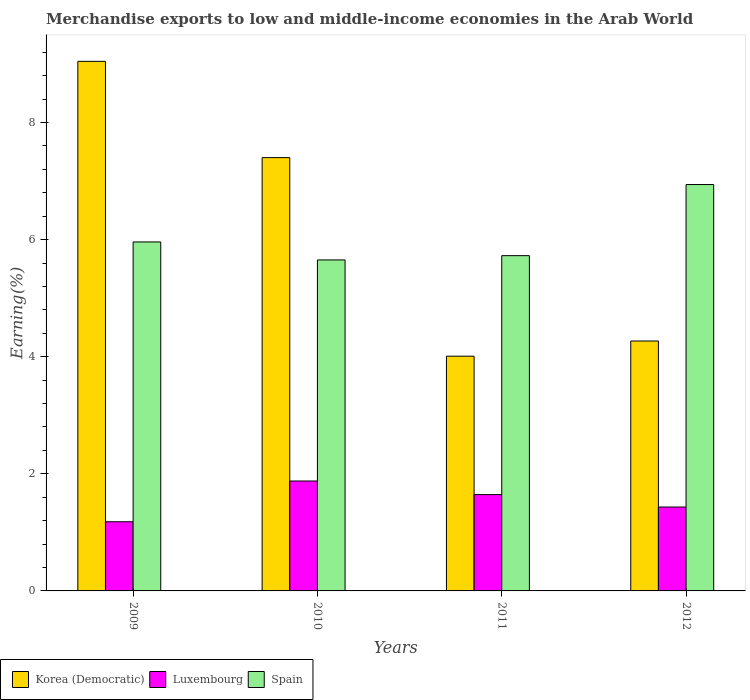How many different coloured bars are there?
Your answer should be compact. 3. How many groups of bars are there?
Give a very brief answer. 4. How many bars are there on the 1st tick from the right?
Keep it short and to the point. 3. What is the percentage of amount earned from merchandise exports in Korea (Democratic) in 2010?
Provide a short and direct response. 7.4. Across all years, what is the maximum percentage of amount earned from merchandise exports in Spain?
Make the answer very short. 6.94. Across all years, what is the minimum percentage of amount earned from merchandise exports in Luxembourg?
Give a very brief answer. 1.18. What is the total percentage of amount earned from merchandise exports in Luxembourg in the graph?
Offer a very short reply. 6.14. What is the difference between the percentage of amount earned from merchandise exports in Korea (Democratic) in 2010 and that in 2011?
Ensure brevity in your answer.  3.39. What is the difference between the percentage of amount earned from merchandise exports in Luxembourg in 2011 and the percentage of amount earned from merchandise exports in Spain in 2009?
Offer a terse response. -4.32. What is the average percentage of amount earned from merchandise exports in Spain per year?
Make the answer very short. 6.07. In the year 2012, what is the difference between the percentage of amount earned from merchandise exports in Luxembourg and percentage of amount earned from merchandise exports in Korea (Democratic)?
Ensure brevity in your answer.  -2.84. What is the ratio of the percentage of amount earned from merchandise exports in Spain in 2010 to that in 2011?
Keep it short and to the point. 0.99. What is the difference between the highest and the second highest percentage of amount earned from merchandise exports in Korea (Democratic)?
Ensure brevity in your answer.  1.64. What is the difference between the highest and the lowest percentage of amount earned from merchandise exports in Spain?
Offer a very short reply. 1.29. Is the sum of the percentage of amount earned from merchandise exports in Spain in 2009 and 2010 greater than the maximum percentage of amount earned from merchandise exports in Korea (Democratic) across all years?
Offer a very short reply. Yes. What does the 2nd bar from the right in 2010 represents?
Offer a very short reply. Luxembourg. How many bars are there?
Your answer should be very brief. 12. Are all the bars in the graph horizontal?
Provide a succinct answer. No. How many years are there in the graph?
Your answer should be compact. 4. What is the difference between two consecutive major ticks on the Y-axis?
Offer a very short reply. 2. Does the graph contain any zero values?
Your response must be concise. No. Does the graph contain grids?
Provide a succinct answer. No. Where does the legend appear in the graph?
Offer a terse response. Bottom left. How are the legend labels stacked?
Keep it short and to the point. Horizontal. What is the title of the graph?
Give a very brief answer. Merchandise exports to low and middle-income economies in the Arab World. Does "Fragile and conflict affected situations" appear as one of the legend labels in the graph?
Keep it short and to the point. No. What is the label or title of the X-axis?
Make the answer very short. Years. What is the label or title of the Y-axis?
Make the answer very short. Earning(%). What is the Earning(%) in Korea (Democratic) in 2009?
Provide a succinct answer. 9.04. What is the Earning(%) of Luxembourg in 2009?
Provide a succinct answer. 1.18. What is the Earning(%) in Spain in 2009?
Offer a very short reply. 5.96. What is the Earning(%) of Korea (Democratic) in 2010?
Make the answer very short. 7.4. What is the Earning(%) in Luxembourg in 2010?
Provide a short and direct response. 1.88. What is the Earning(%) of Spain in 2010?
Your response must be concise. 5.65. What is the Earning(%) in Korea (Democratic) in 2011?
Ensure brevity in your answer.  4.01. What is the Earning(%) of Luxembourg in 2011?
Offer a very short reply. 1.65. What is the Earning(%) of Spain in 2011?
Your response must be concise. 5.73. What is the Earning(%) in Korea (Democratic) in 2012?
Make the answer very short. 4.27. What is the Earning(%) of Luxembourg in 2012?
Keep it short and to the point. 1.43. What is the Earning(%) in Spain in 2012?
Provide a succinct answer. 6.94. Across all years, what is the maximum Earning(%) of Korea (Democratic)?
Offer a very short reply. 9.04. Across all years, what is the maximum Earning(%) in Luxembourg?
Your answer should be very brief. 1.88. Across all years, what is the maximum Earning(%) of Spain?
Provide a succinct answer. 6.94. Across all years, what is the minimum Earning(%) in Korea (Democratic)?
Your answer should be compact. 4.01. Across all years, what is the minimum Earning(%) of Luxembourg?
Make the answer very short. 1.18. Across all years, what is the minimum Earning(%) in Spain?
Make the answer very short. 5.65. What is the total Earning(%) of Korea (Democratic) in the graph?
Ensure brevity in your answer.  24.72. What is the total Earning(%) in Luxembourg in the graph?
Ensure brevity in your answer.  6.14. What is the total Earning(%) in Spain in the graph?
Your answer should be very brief. 24.28. What is the difference between the Earning(%) in Korea (Democratic) in 2009 and that in 2010?
Provide a short and direct response. 1.64. What is the difference between the Earning(%) in Luxembourg in 2009 and that in 2010?
Your answer should be very brief. -0.7. What is the difference between the Earning(%) in Spain in 2009 and that in 2010?
Provide a short and direct response. 0.31. What is the difference between the Earning(%) of Korea (Democratic) in 2009 and that in 2011?
Offer a very short reply. 5.04. What is the difference between the Earning(%) in Luxembourg in 2009 and that in 2011?
Ensure brevity in your answer.  -0.46. What is the difference between the Earning(%) of Spain in 2009 and that in 2011?
Give a very brief answer. 0.23. What is the difference between the Earning(%) of Korea (Democratic) in 2009 and that in 2012?
Offer a very short reply. 4.78. What is the difference between the Earning(%) of Luxembourg in 2009 and that in 2012?
Your answer should be very brief. -0.25. What is the difference between the Earning(%) in Spain in 2009 and that in 2012?
Provide a short and direct response. -0.98. What is the difference between the Earning(%) of Korea (Democratic) in 2010 and that in 2011?
Provide a short and direct response. 3.39. What is the difference between the Earning(%) of Luxembourg in 2010 and that in 2011?
Make the answer very short. 0.23. What is the difference between the Earning(%) in Spain in 2010 and that in 2011?
Make the answer very short. -0.07. What is the difference between the Earning(%) of Korea (Democratic) in 2010 and that in 2012?
Your answer should be compact. 3.13. What is the difference between the Earning(%) of Luxembourg in 2010 and that in 2012?
Offer a very short reply. 0.44. What is the difference between the Earning(%) of Spain in 2010 and that in 2012?
Give a very brief answer. -1.29. What is the difference between the Earning(%) in Korea (Democratic) in 2011 and that in 2012?
Offer a very short reply. -0.26. What is the difference between the Earning(%) in Luxembourg in 2011 and that in 2012?
Provide a short and direct response. 0.21. What is the difference between the Earning(%) in Spain in 2011 and that in 2012?
Ensure brevity in your answer.  -1.21. What is the difference between the Earning(%) in Korea (Democratic) in 2009 and the Earning(%) in Luxembourg in 2010?
Keep it short and to the point. 7.17. What is the difference between the Earning(%) of Korea (Democratic) in 2009 and the Earning(%) of Spain in 2010?
Give a very brief answer. 3.39. What is the difference between the Earning(%) in Luxembourg in 2009 and the Earning(%) in Spain in 2010?
Keep it short and to the point. -4.47. What is the difference between the Earning(%) in Korea (Democratic) in 2009 and the Earning(%) in Luxembourg in 2011?
Your answer should be very brief. 7.4. What is the difference between the Earning(%) of Korea (Democratic) in 2009 and the Earning(%) of Spain in 2011?
Keep it short and to the point. 3.32. What is the difference between the Earning(%) of Luxembourg in 2009 and the Earning(%) of Spain in 2011?
Ensure brevity in your answer.  -4.54. What is the difference between the Earning(%) in Korea (Democratic) in 2009 and the Earning(%) in Luxembourg in 2012?
Provide a short and direct response. 7.61. What is the difference between the Earning(%) of Korea (Democratic) in 2009 and the Earning(%) of Spain in 2012?
Give a very brief answer. 2.1. What is the difference between the Earning(%) in Luxembourg in 2009 and the Earning(%) in Spain in 2012?
Make the answer very short. -5.76. What is the difference between the Earning(%) of Korea (Democratic) in 2010 and the Earning(%) of Luxembourg in 2011?
Ensure brevity in your answer.  5.76. What is the difference between the Earning(%) in Korea (Democratic) in 2010 and the Earning(%) in Spain in 2011?
Your answer should be compact. 1.67. What is the difference between the Earning(%) of Luxembourg in 2010 and the Earning(%) of Spain in 2011?
Your answer should be very brief. -3.85. What is the difference between the Earning(%) of Korea (Democratic) in 2010 and the Earning(%) of Luxembourg in 2012?
Provide a succinct answer. 5.97. What is the difference between the Earning(%) of Korea (Democratic) in 2010 and the Earning(%) of Spain in 2012?
Give a very brief answer. 0.46. What is the difference between the Earning(%) in Luxembourg in 2010 and the Earning(%) in Spain in 2012?
Your response must be concise. -5.06. What is the difference between the Earning(%) of Korea (Democratic) in 2011 and the Earning(%) of Luxembourg in 2012?
Your answer should be compact. 2.58. What is the difference between the Earning(%) of Korea (Democratic) in 2011 and the Earning(%) of Spain in 2012?
Your answer should be compact. -2.93. What is the difference between the Earning(%) in Luxembourg in 2011 and the Earning(%) in Spain in 2012?
Provide a succinct answer. -5.3. What is the average Earning(%) in Korea (Democratic) per year?
Your response must be concise. 6.18. What is the average Earning(%) of Luxembourg per year?
Give a very brief answer. 1.53. What is the average Earning(%) of Spain per year?
Provide a succinct answer. 6.07. In the year 2009, what is the difference between the Earning(%) in Korea (Democratic) and Earning(%) in Luxembourg?
Offer a terse response. 7.86. In the year 2009, what is the difference between the Earning(%) in Korea (Democratic) and Earning(%) in Spain?
Provide a short and direct response. 3.08. In the year 2009, what is the difference between the Earning(%) in Luxembourg and Earning(%) in Spain?
Offer a terse response. -4.78. In the year 2010, what is the difference between the Earning(%) of Korea (Democratic) and Earning(%) of Luxembourg?
Your answer should be compact. 5.52. In the year 2010, what is the difference between the Earning(%) of Korea (Democratic) and Earning(%) of Spain?
Provide a succinct answer. 1.75. In the year 2010, what is the difference between the Earning(%) in Luxembourg and Earning(%) in Spain?
Provide a succinct answer. -3.78. In the year 2011, what is the difference between the Earning(%) of Korea (Democratic) and Earning(%) of Luxembourg?
Your answer should be compact. 2.36. In the year 2011, what is the difference between the Earning(%) in Korea (Democratic) and Earning(%) in Spain?
Provide a succinct answer. -1.72. In the year 2011, what is the difference between the Earning(%) of Luxembourg and Earning(%) of Spain?
Ensure brevity in your answer.  -4.08. In the year 2012, what is the difference between the Earning(%) of Korea (Democratic) and Earning(%) of Luxembourg?
Provide a succinct answer. 2.84. In the year 2012, what is the difference between the Earning(%) of Korea (Democratic) and Earning(%) of Spain?
Your answer should be very brief. -2.67. In the year 2012, what is the difference between the Earning(%) of Luxembourg and Earning(%) of Spain?
Keep it short and to the point. -5.51. What is the ratio of the Earning(%) in Korea (Democratic) in 2009 to that in 2010?
Provide a succinct answer. 1.22. What is the ratio of the Earning(%) in Luxembourg in 2009 to that in 2010?
Provide a short and direct response. 0.63. What is the ratio of the Earning(%) in Spain in 2009 to that in 2010?
Your answer should be compact. 1.05. What is the ratio of the Earning(%) of Korea (Democratic) in 2009 to that in 2011?
Your response must be concise. 2.26. What is the ratio of the Earning(%) in Luxembourg in 2009 to that in 2011?
Provide a short and direct response. 0.72. What is the ratio of the Earning(%) in Spain in 2009 to that in 2011?
Your answer should be very brief. 1.04. What is the ratio of the Earning(%) of Korea (Democratic) in 2009 to that in 2012?
Make the answer very short. 2.12. What is the ratio of the Earning(%) in Luxembourg in 2009 to that in 2012?
Provide a short and direct response. 0.82. What is the ratio of the Earning(%) in Spain in 2009 to that in 2012?
Provide a short and direct response. 0.86. What is the ratio of the Earning(%) in Korea (Democratic) in 2010 to that in 2011?
Give a very brief answer. 1.85. What is the ratio of the Earning(%) of Luxembourg in 2010 to that in 2011?
Keep it short and to the point. 1.14. What is the ratio of the Earning(%) of Spain in 2010 to that in 2011?
Provide a succinct answer. 0.99. What is the ratio of the Earning(%) of Korea (Democratic) in 2010 to that in 2012?
Provide a short and direct response. 1.73. What is the ratio of the Earning(%) of Luxembourg in 2010 to that in 2012?
Give a very brief answer. 1.31. What is the ratio of the Earning(%) of Spain in 2010 to that in 2012?
Your answer should be compact. 0.81. What is the ratio of the Earning(%) in Korea (Democratic) in 2011 to that in 2012?
Provide a short and direct response. 0.94. What is the ratio of the Earning(%) in Luxembourg in 2011 to that in 2012?
Your answer should be very brief. 1.15. What is the ratio of the Earning(%) in Spain in 2011 to that in 2012?
Your response must be concise. 0.82. What is the difference between the highest and the second highest Earning(%) in Korea (Democratic)?
Give a very brief answer. 1.64. What is the difference between the highest and the second highest Earning(%) of Luxembourg?
Make the answer very short. 0.23. What is the difference between the highest and the second highest Earning(%) in Spain?
Your answer should be very brief. 0.98. What is the difference between the highest and the lowest Earning(%) in Korea (Democratic)?
Provide a succinct answer. 5.04. What is the difference between the highest and the lowest Earning(%) in Luxembourg?
Offer a very short reply. 0.7. What is the difference between the highest and the lowest Earning(%) of Spain?
Your answer should be compact. 1.29. 